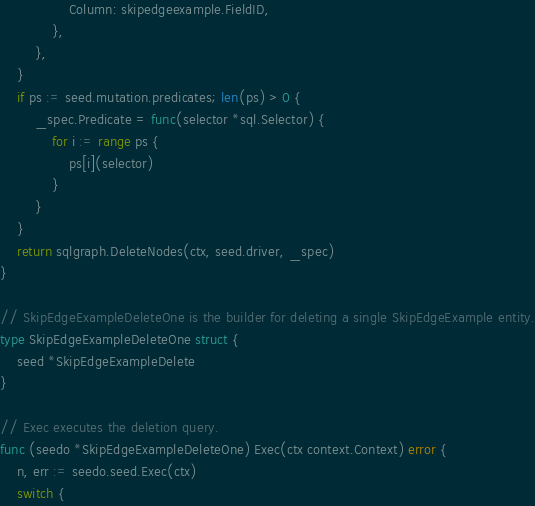Convert code to text. <code><loc_0><loc_0><loc_500><loc_500><_Go_>				Column: skipedgeexample.FieldID,
			},
		},
	}
	if ps := seed.mutation.predicates; len(ps) > 0 {
		_spec.Predicate = func(selector *sql.Selector) {
			for i := range ps {
				ps[i](selector)
			}
		}
	}
	return sqlgraph.DeleteNodes(ctx, seed.driver, _spec)
}

// SkipEdgeExampleDeleteOne is the builder for deleting a single SkipEdgeExample entity.
type SkipEdgeExampleDeleteOne struct {
	seed *SkipEdgeExampleDelete
}

// Exec executes the deletion query.
func (seedo *SkipEdgeExampleDeleteOne) Exec(ctx context.Context) error {
	n, err := seedo.seed.Exec(ctx)
	switch {</code> 